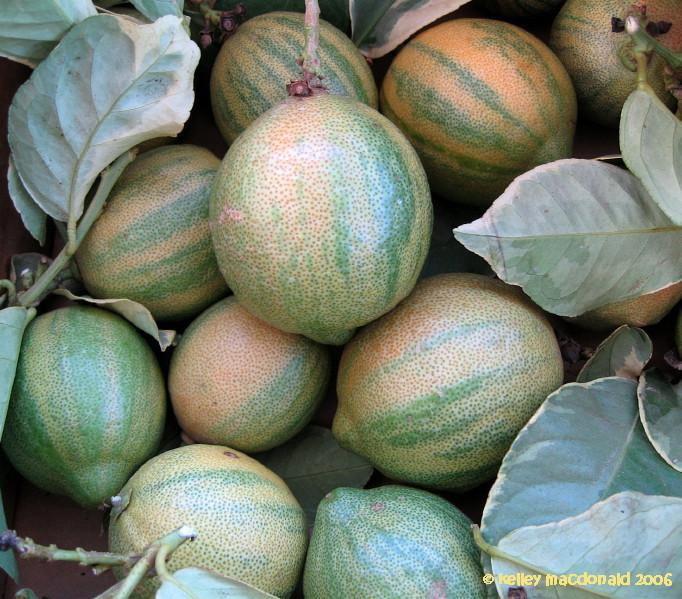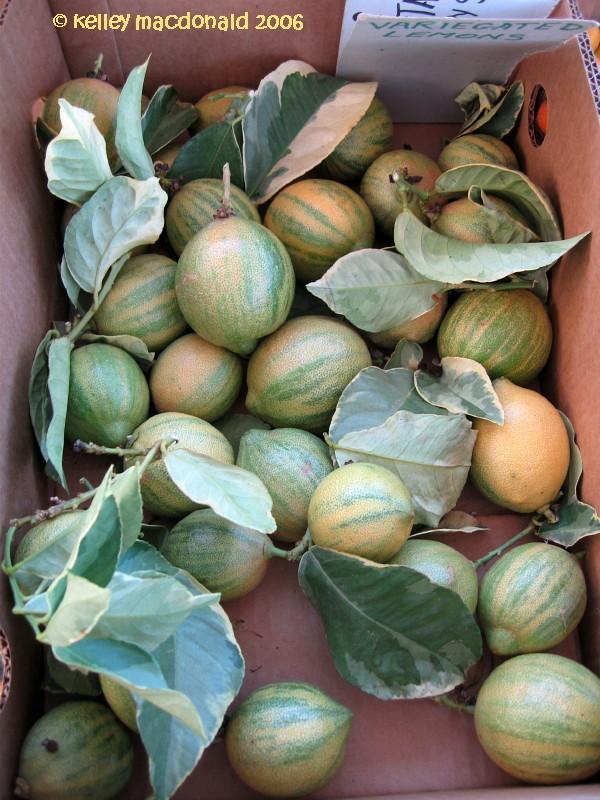The first image is the image on the left, the second image is the image on the right. For the images shown, is this caption "There are lemon trees in both images." true? Answer yes or no. No. 